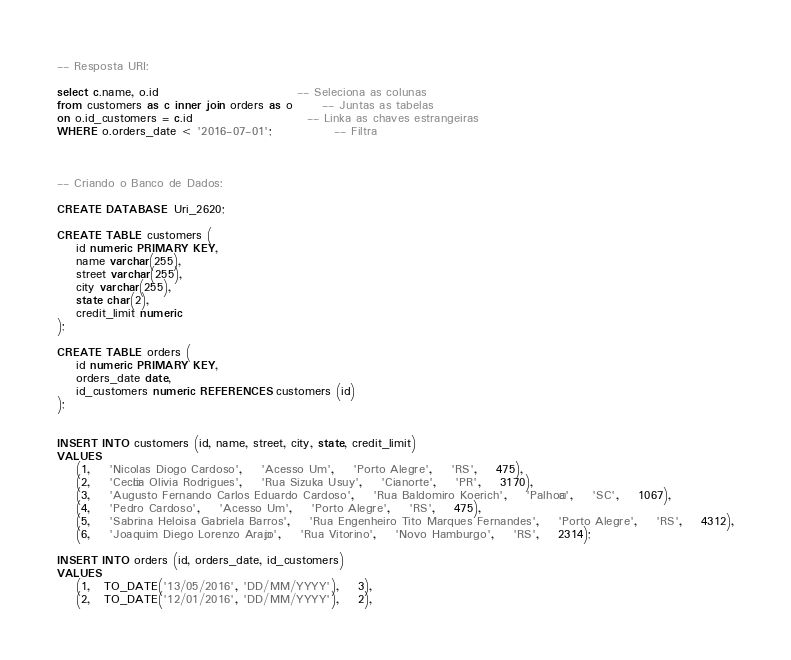Convert code to text. <code><loc_0><loc_0><loc_500><loc_500><_SQL_>-- Resposta URI:

select c.name, o.id                             -- Seleciona as colunas
from customers as c inner join orders as o      -- Juntas as tabelas
on o.id_customers = c.id                        -- Linka as chaves estrangeiras
WHERE o.orders_date < '2016-07-01';             -- Filtra



-- Criando o Banco de Dados:

CREATE DATABASE Uri_2620;

CREATE TABLE customers (
    id numeric PRIMARY KEY,
    name varchar(255),
    street varchar(255),
    city varchar(255),
    state char(2),
    credit_limit numeric
);

CREATE TABLE orders (
    id numeric PRIMARY KEY,
    orders_date date,
    id_customers numeric REFERENCES customers (id)
);


INSERT INTO customers (id, name, street, city, state, credit_limit)
VALUES
    (1,	'Nicolas Diogo Cardoso',	'Acesso Um',	'Porto Alegre',	'RS',	475),
    (2,	'Cecília Olivia Rodrigues',	'Rua Sizuka Usuy',	'Cianorte',	'PR',	3170),
    (3,	'Augusto Fernando Carlos Eduardo Cardoso',	'Rua Baldomiro Koerich',	'Palhoça',	'SC',	1067),
    (4,	'Pedro Cardoso',	'Acesso Um',	'Porto Alegre',	'RS',	475),
    (5,	'Sabrina Heloisa Gabriela Barros',	'Rua Engenheiro Tito Marques Fernandes',	'Porto Alegre',	'RS',	4312),
    (6,	'Joaquim Diego Lorenzo Araújo',	'Rua Vitorino',	'Novo Hamburgo',	'RS',	2314);

INSERT INTO orders (id, orders_date, id_customers)
VALUES
    (1,   TO_DATE('13/05/2016', 'DD/MM/YYYY'),    3),
    (2,   TO_DATE('12/01/2016', 'DD/MM/YYYY'),    2),</code> 